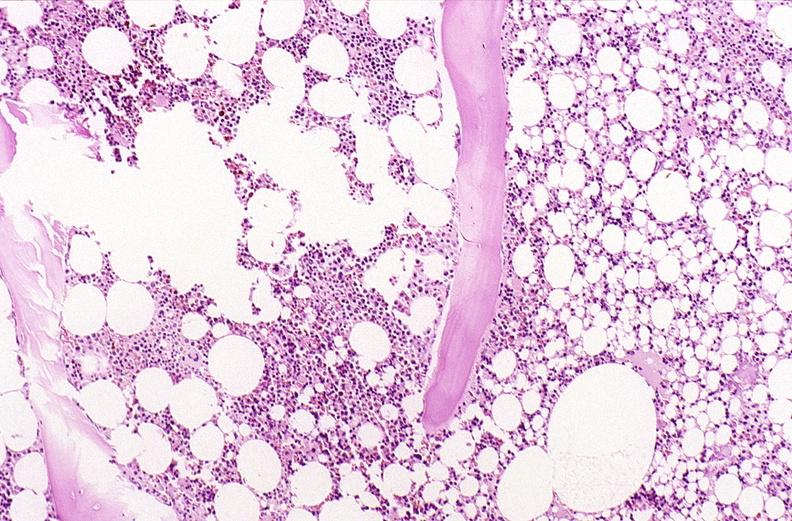does lesion show bone, vertebral body opsteopenia, osteoporosis?
Answer the question using a single word or phrase. No 